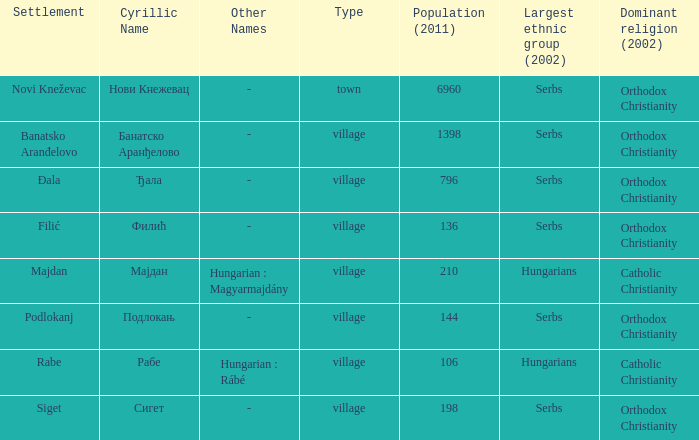How would one categorize the settlement of rabe? Village. 